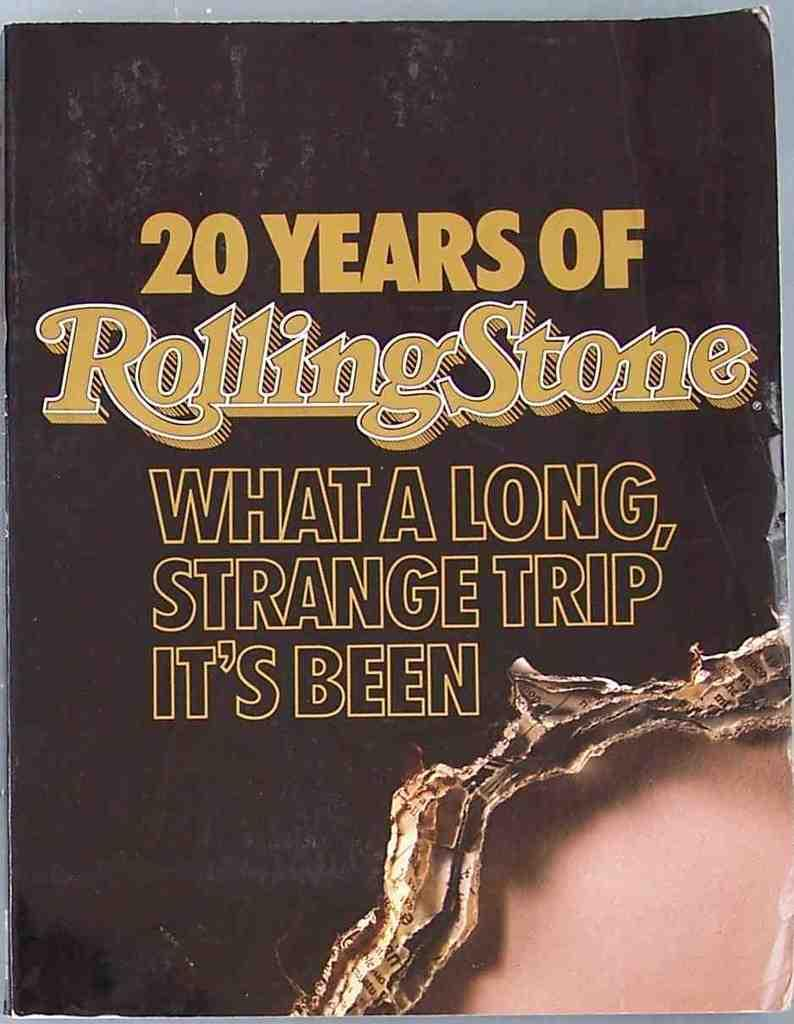<image>
Summarize the visual content of the image. A very old copy of Rolling Stone is printed with What a Long, Strange Trip It's Been. 